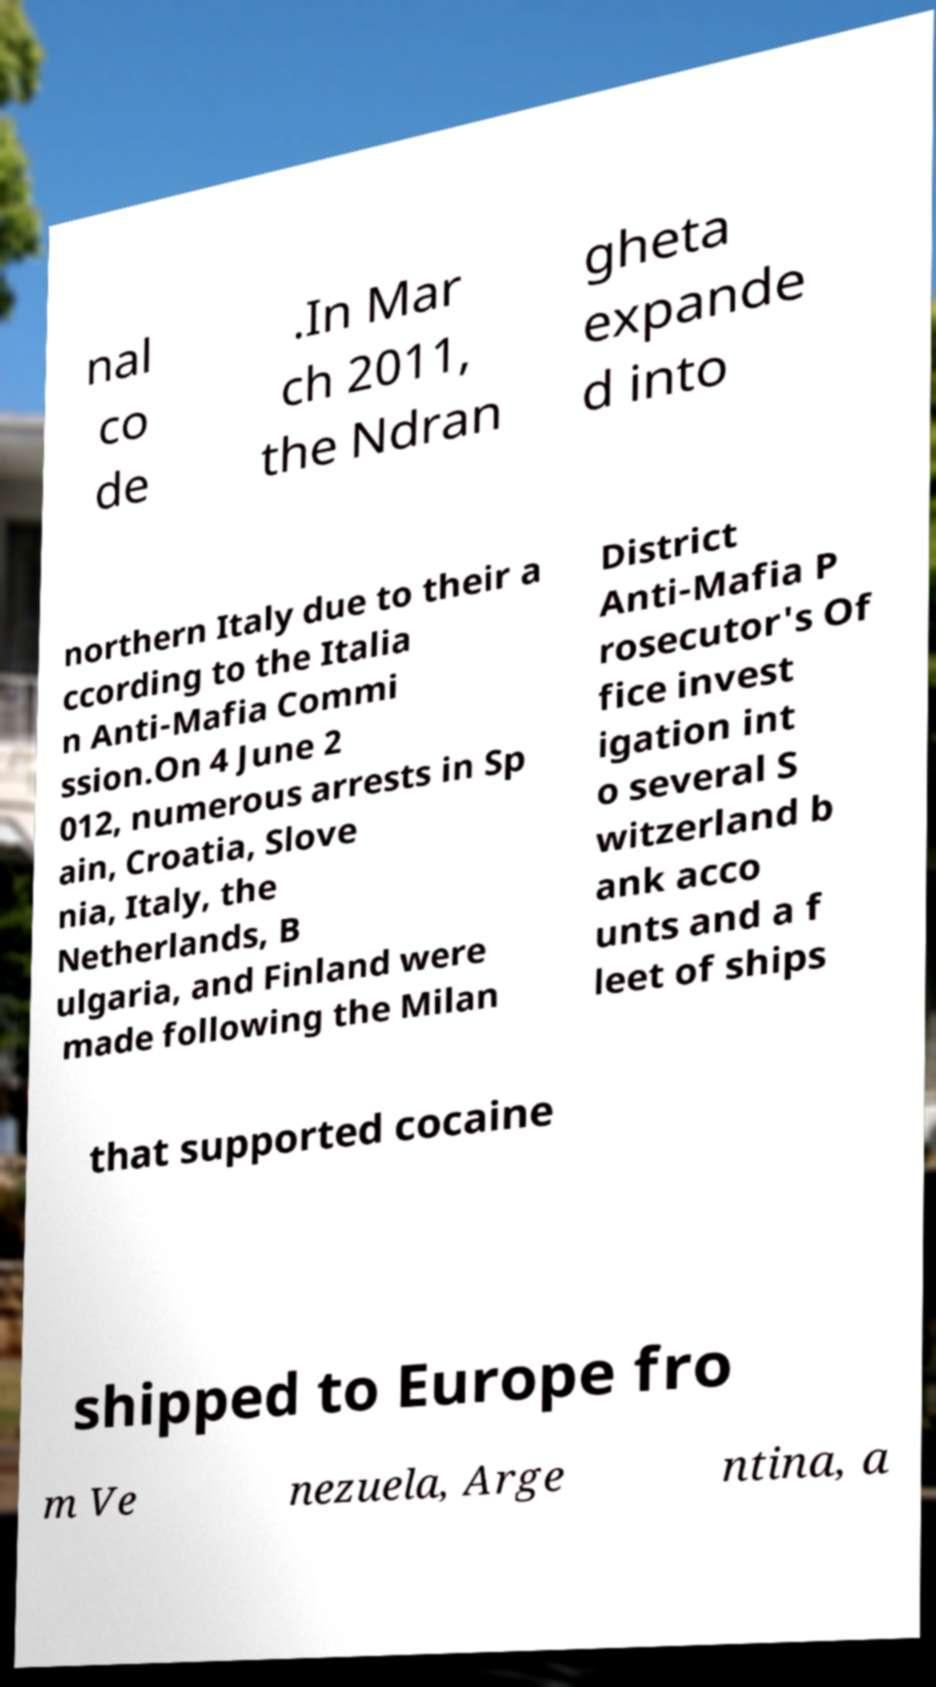I need the written content from this picture converted into text. Can you do that? nal co de .In Mar ch 2011, the Ndran gheta expande d into northern Italy due to their a ccording to the Italia n Anti-Mafia Commi ssion.On 4 June 2 012, numerous arrests in Sp ain, Croatia, Slove nia, Italy, the Netherlands, B ulgaria, and Finland were made following the Milan District Anti-Mafia P rosecutor's Of fice invest igation int o several S witzerland b ank acco unts and a f leet of ships that supported cocaine shipped to Europe fro m Ve nezuela, Arge ntina, a 